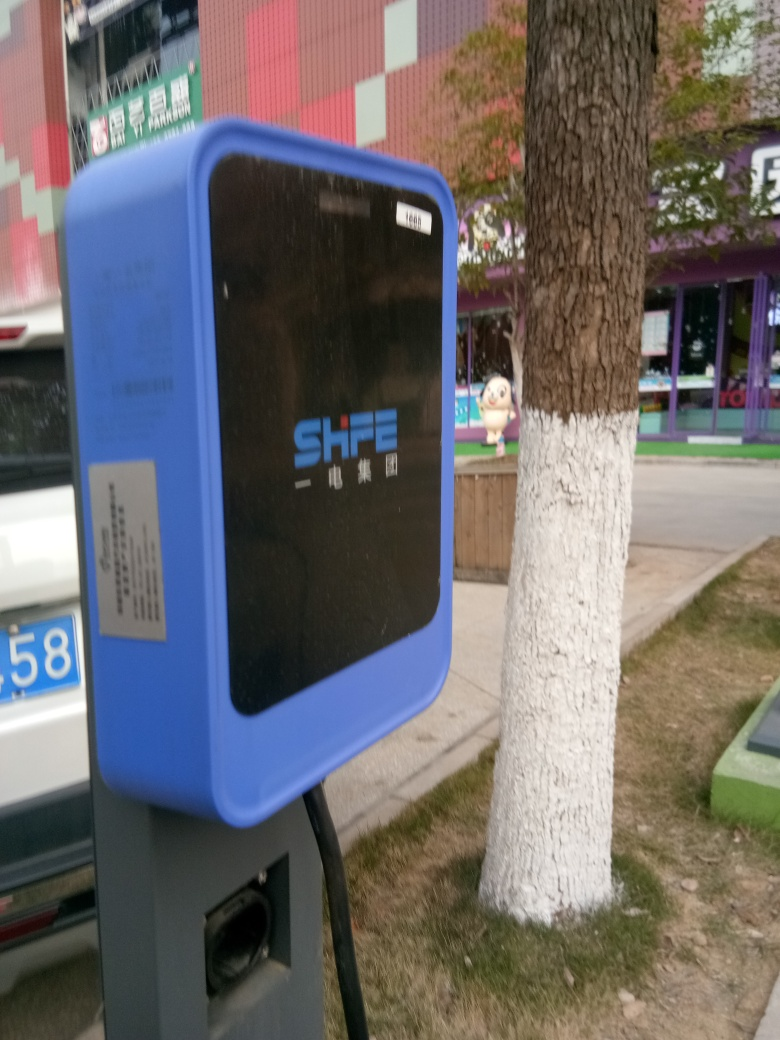What can you infer about the location based on this image? The image suggests a moderately urban area, as indicated by the presence of a charging station, painted cityscape on a wall, and the cartoon figure, which could imply a nearby recreational or shopping area. The text on the charging station suggests a non-English speaking country, possibly in East Asia. What does the presence of an EV charging station indicate about this area? The presence of an EV charging station indicates that the area is adapting to eco-friendly transportation solutions and promoting electric vehicle usage. It also hints at an infrastructure that supports modern technology and a population that might be environmentally conscious. 